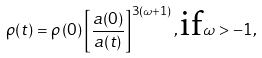Convert formula to latex. <formula><loc_0><loc_0><loc_500><loc_500>\rho ( t ) = \rho \left ( 0 \right ) \left [ \frac { a ( 0 ) } { a ( t ) } \right ] ^ { 3 ( \omega + 1 ) } , \text {if} \omega > - 1 ,</formula> 